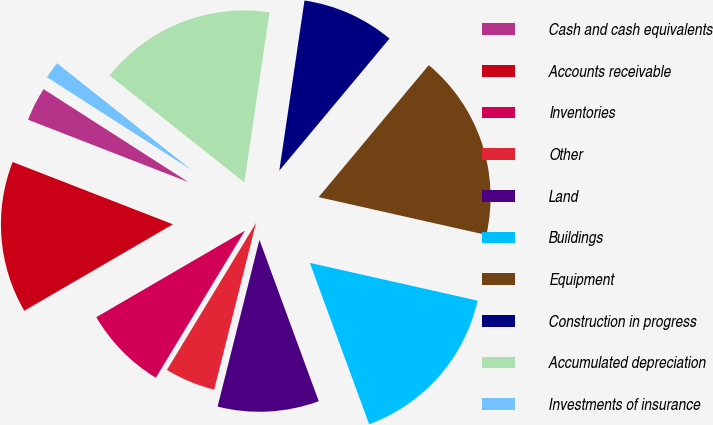Convert chart. <chart><loc_0><loc_0><loc_500><loc_500><pie_chart><fcel>Cash and cash equivalents<fcel>Accounts receivable<fcel>Inventories<fcel>Other<fcel>Land<fcel>Buildings<fcel>Equipment<fcel>Construction in progress<fcel>Accumulated depreciation<fcel>Investments of insurance<nl><fcel>3.18%<fcel>14.29%<fcel>7.94%<fcel>4.76%<fcel>9.52%<fcel>15.87%<fcel>17.46%<fcel>8.73%<fcel>16.67%<fcel>1.59%<nl></chart> 